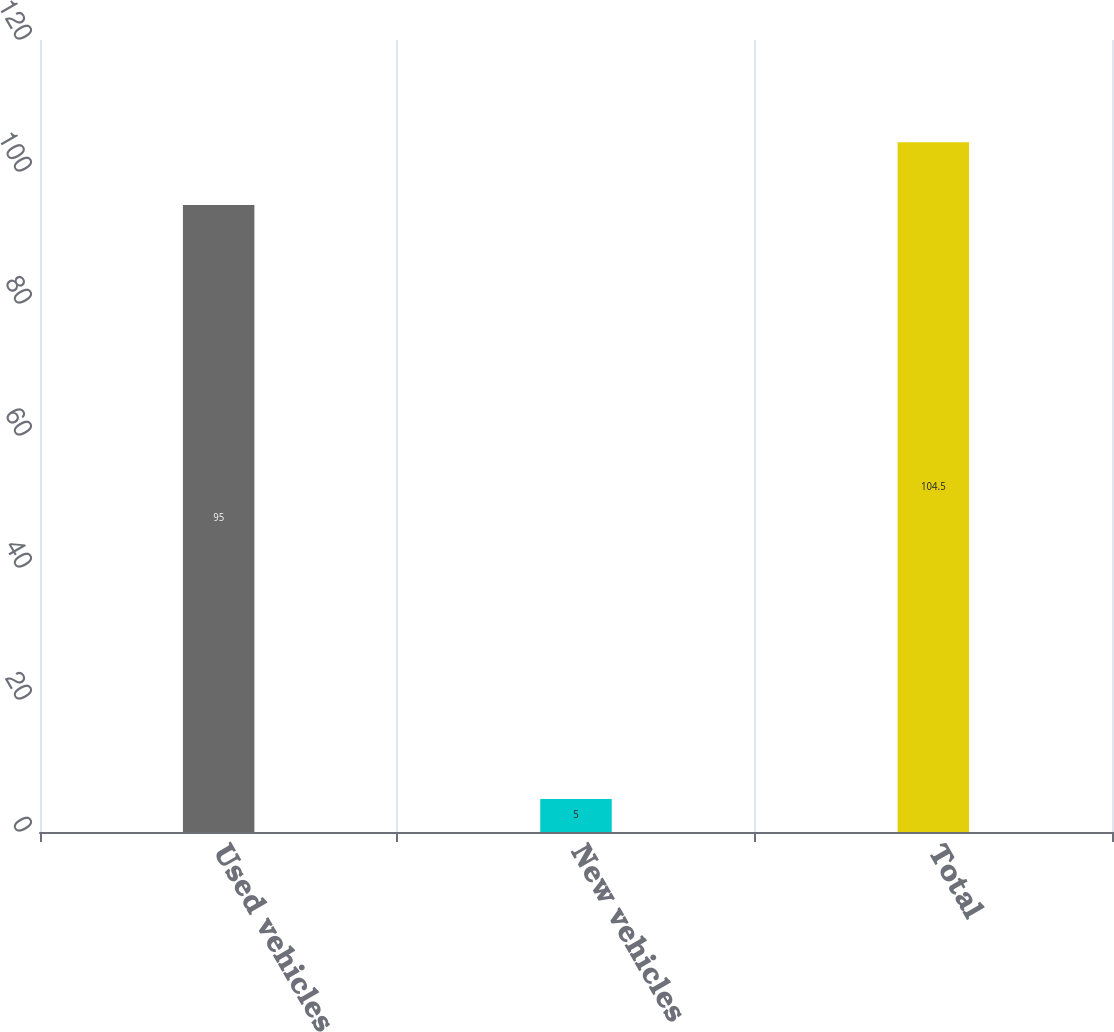Convert chart. <chart><loc_0><loc_0><loc_500><loc_500><bar_chart><fcel>Used vehicles<fcel>New vehicles<fcel>Total<nl><fcel>95<fcel>5<fcel>104.5<nl></chart> 